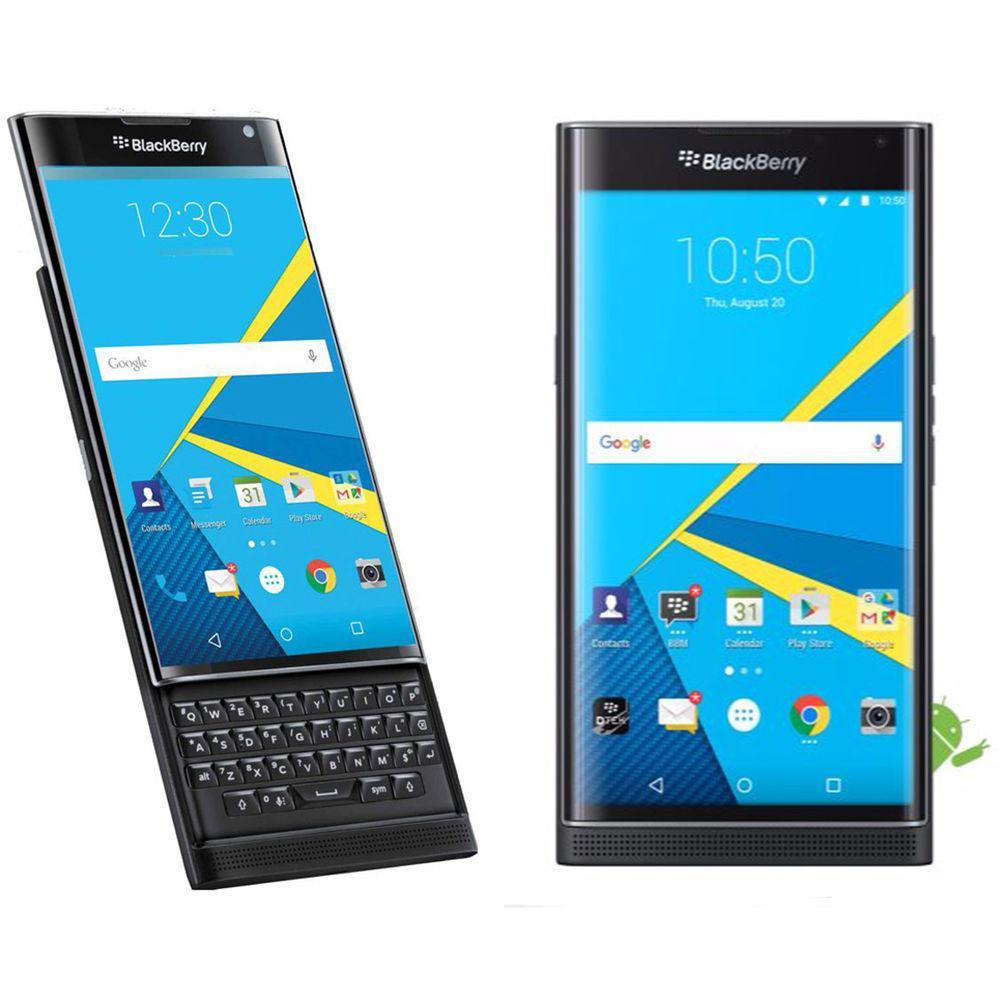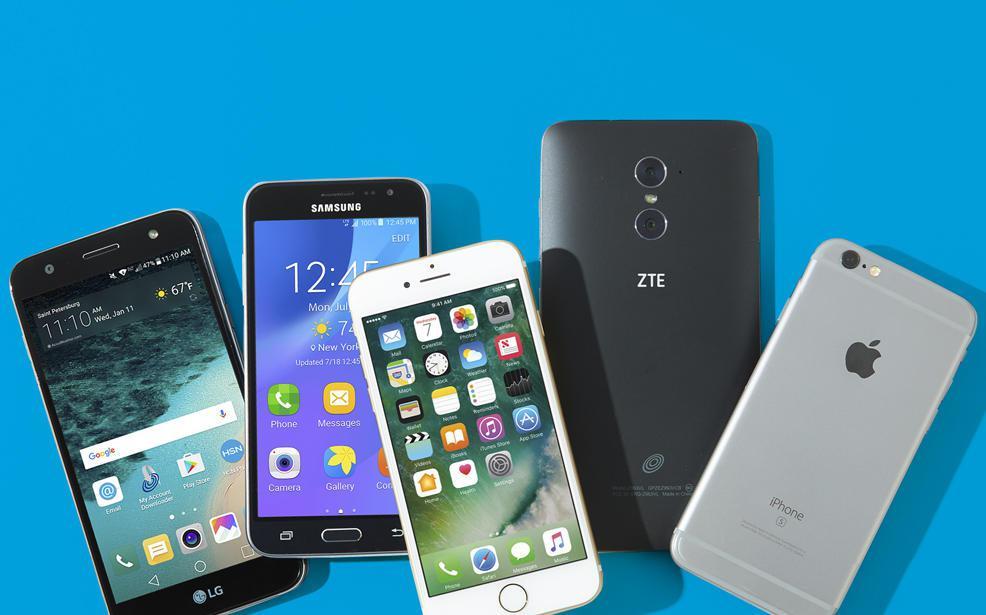The first image is the image on the left, the second image is the image on the right. Assess this claim about the two images: "The image on the left shows one smartphone, face up on a wood table.". Correct or not? Answer yes or no. No. The first image is the image on the left, the second image is the image on the right. For the images displayed, is the sentence "The back of a phone is visible." factually correct? Answer yes or no. Yes. 